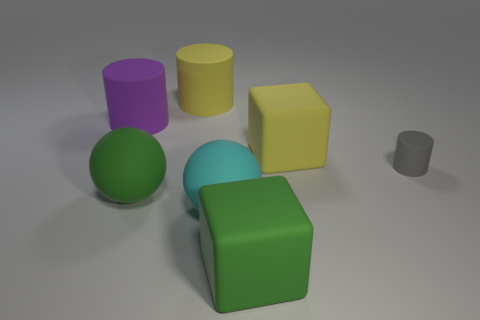Are there any other things that have the same size as the gray thing?
Make the answer very short. No. How many cyan matte things are there?
Keep it short and to the point. 1. Is the color of the rubber thing behind the large purple rubber thing the same as the rubber object that is on the right side of the big yellow rubber block?
Ensure brevity in your answer.  No. What number of things are behind the large cyan sphere?
Your answer should be very brief. 5. Are there any big yellow matte things of the same shape as the gray rubber object?
Keep it short and to the point. Yes. Do the yellow thing behind the large yellow block and the cylinder that is in front of the purple rubber cylinder have the same material?
Make the answer very short. Yes. There is a cube that is in front of the matte block behind the big green object that is to the right of the cyan object; how big is it?
Your response must be concise. Large. Is there a block of the same size as the green ball?
Keep it short and to the point. Yes. Does the purple thing have the same shape as the tiny gray object?
Your answer should be compact. Yes. There is a large yellow object on the right side of the big cube that is in front of the small cylinder; is there a tiny object on the left side of it?
Give a very brief answer. No. 